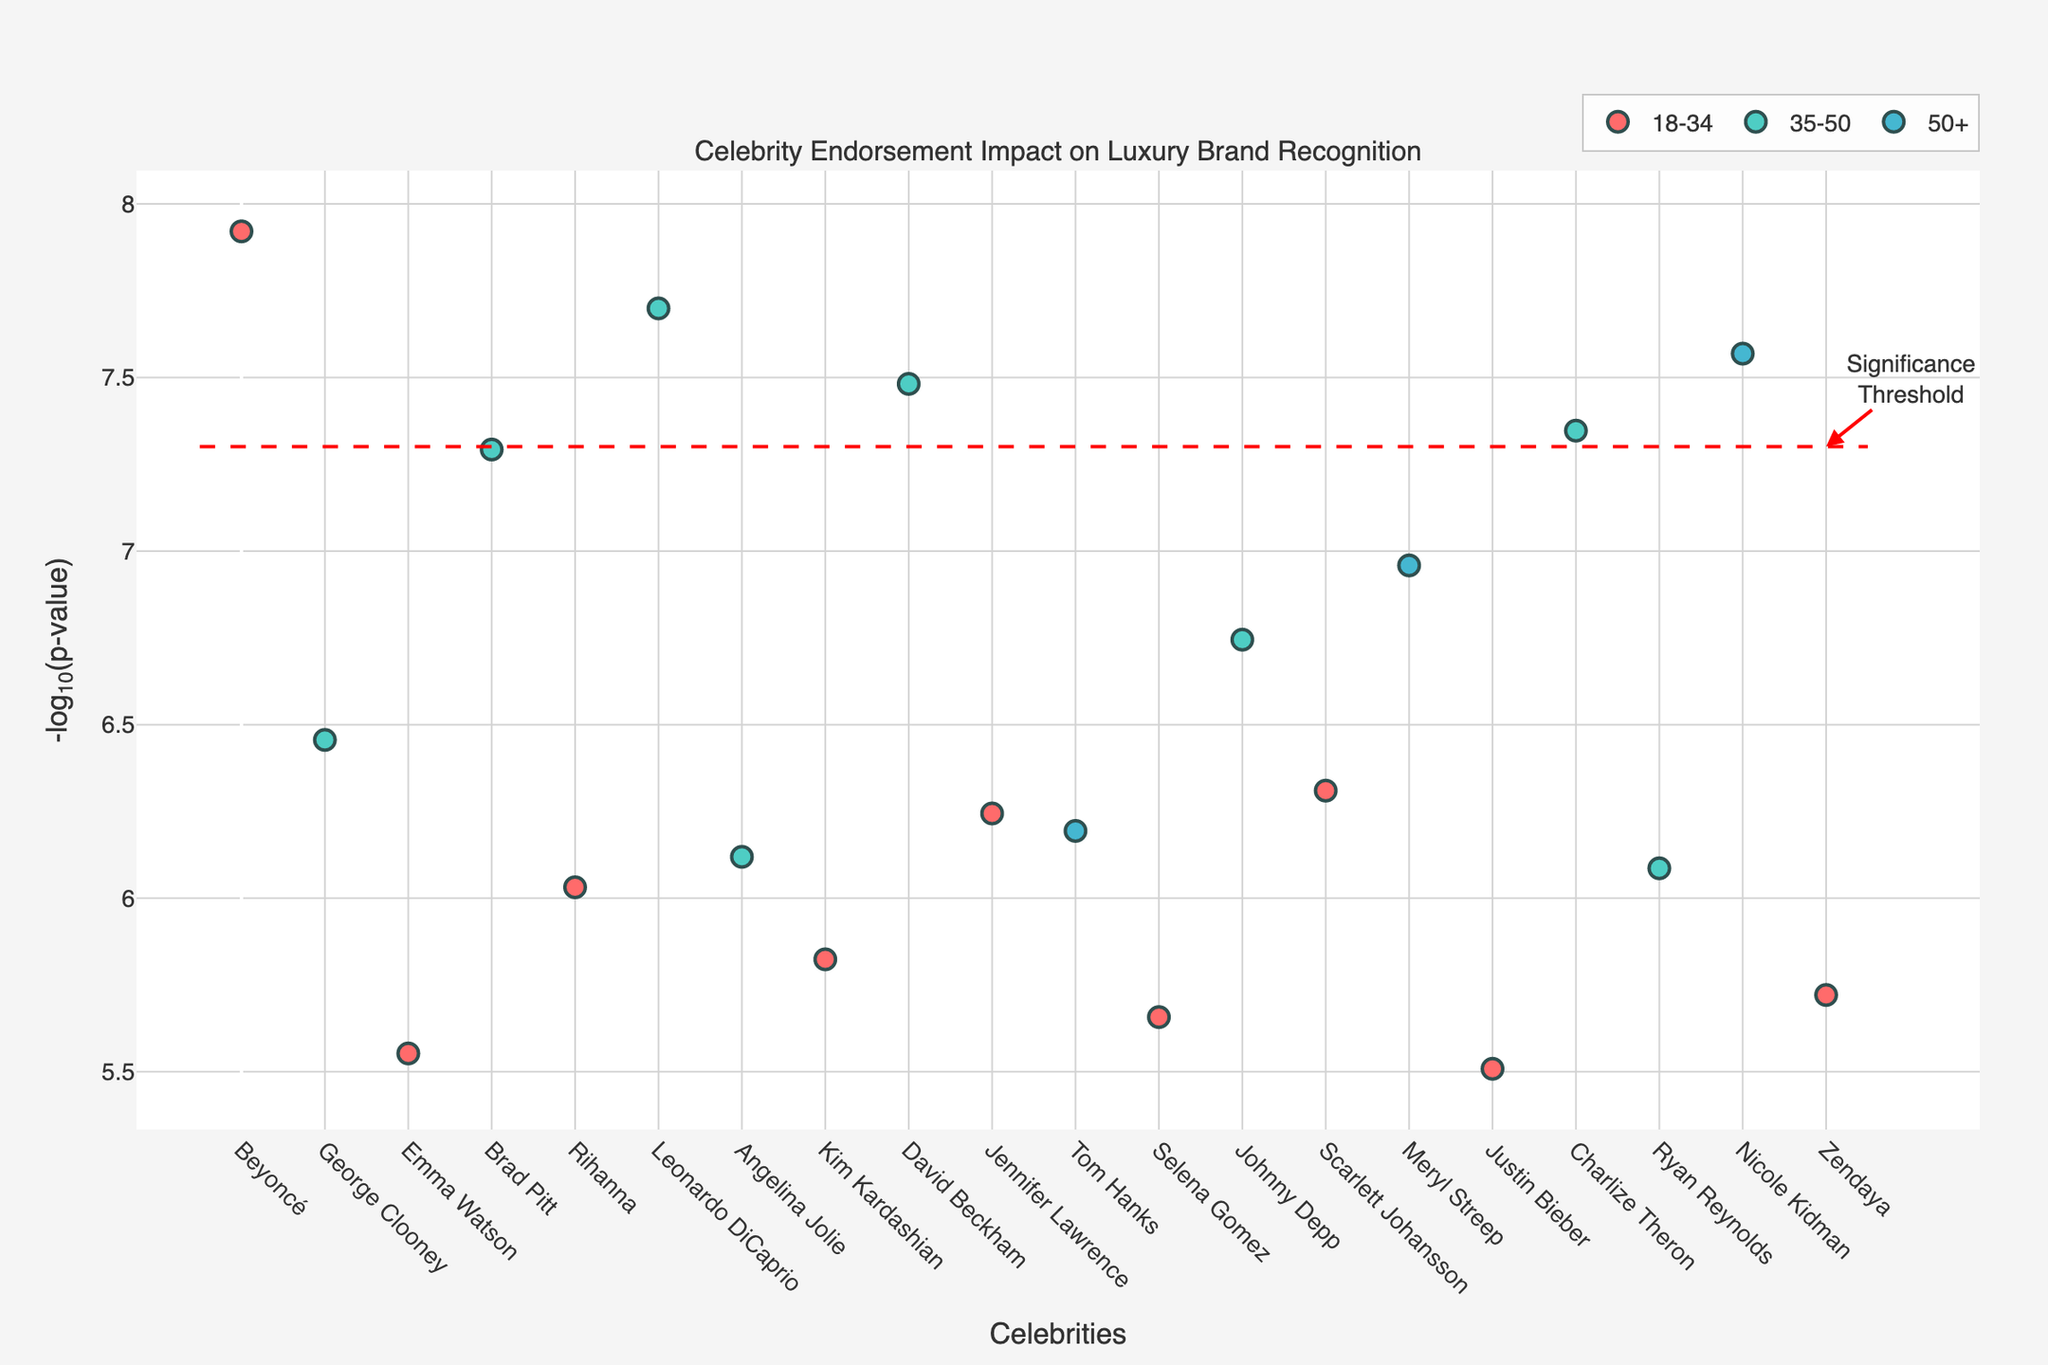What is the title of the plot? The title is displayed at the top of the figure and indicates what the plot is about. The title here is “Celebrity Endorsement Impact on Luxury Brand Recognition.”
Answer: Celebrity Endorsement Impact on Luxury Brand Recognition What does the x-axis represent? The x-axis represents the celebrities. Each tick on the x-axis is labeled with the name of a celebrity.
Answer: Celebrities What does the y-axis represent? The y-axis represents the negative log10 of the p-value.
Answer: -log10(p-value) How many age groups are represented in the plot? To determine this, look at the legend, which shows distinct colors for each age group. There are three age groups listed.
Answer: 3 Which age group has the most data points? Count the number of points in each color corresponding to the age groups shown in the legend. The age group "18-34" has the most data points.
Answer: 18-34 Which celebrity has the highest brand recognition score? The brand recognition score is part of the hover text. By examining hover texts, Beyoncé, with an endorsement score of 89, has the highest score among the celebrities.
Answer: Beyoncé What does the dashed red horizontal line represent? The dashed red horizontal line represents the significance threshold. This contextual information is given by an annotation next to the line in the plot.
Answer: Significance Threshold How many celebrities have a p-value smaller than the significance threshold? Celebrities with -log10(p-value) above the red dashed line meet the threshold. Counting these points gives us the answer. There are six celebrities above the red line.
Answer: 6 Which celebrity in the 35-50 age group has the lowest p-value? To find the lowest p-value, look for the highest -log10(p-value) in the 35-50 age group. Brad Pitt shows the highest -log10(p-value) in this group.
Answer: Brad Pitt Is there a noticeable trend in brand recognition scores among the age groups depicted? By examining the hover text and plotting data points, one observes no clear increasing or decreasing trend across the age groups in brand recognition scores. Each age group shows varied brand recognition scores.
Answer: No clear trend 